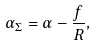Convert formula to latex. <formula><loc_0><loc_0><loc_500><loc_500>\alpha _ { \Sigma } = \alpha - \frac { f } { R } ,</formula> 